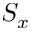<formula> <loc_0><loc_0><loc_500><loc_500>S _ { x }</formula> 